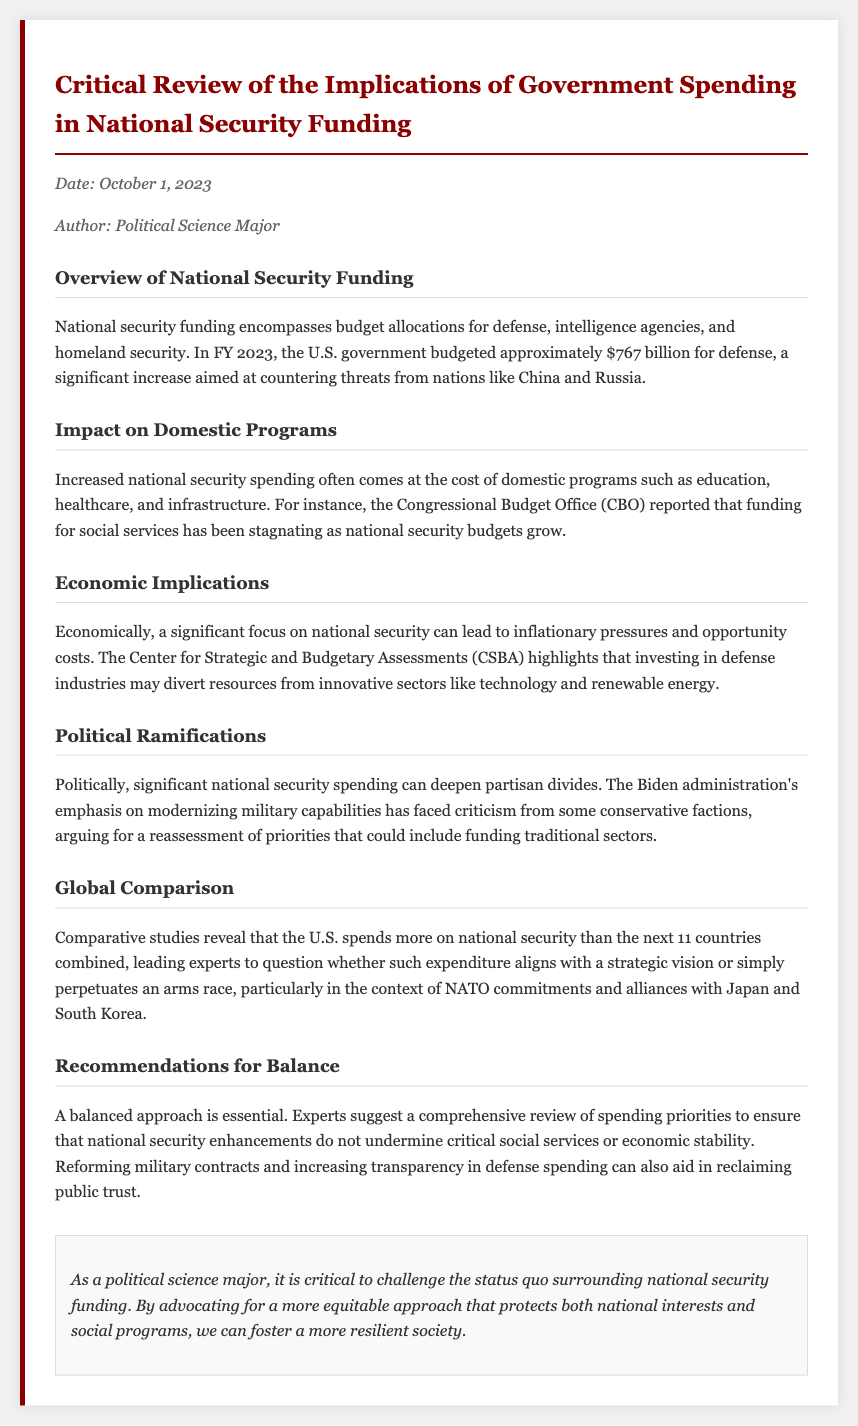What is the budgeted amount for defense in FY 2023? The document states that the U.S. government budgeted approximately $767 billion for defense in FY 2023.
Answer: $767 billion What impact does increased national security spending have on domestic programs? Increased national security spending often comes at the cost of domestic programs such as education and healthcare.
Answer: Cost What is one of the economic implications of focusing on national security? The document mentions inflationary pressures and opportunity costs as economic implications of significant focus on national security.
Answer: Inflationary pressures Which administration's military modernization has faced criticism from conservative factions? The Biden administration's emphasis on modernizing military capabilities is mentioned as facing criticism.
Answer: Biden administration How does U.S. national security spending compare globally? The document states that the U.S. spends more on national security than the next 11 countries combined.
Answer: More What do experts recommend to ensure balance in national security spending? The document suggests a comprehensive review of spending priorities to avoid undermining social services.
Answer: Comprehensive review What is a recommendation made for reclaiming public trust in defense spending? Reforming military contracts and increasing transparency is recommended to reclaim public trust.
Answer: Increasing transparency What is the date of this memo? The memo is dated October 1, 2023.
Answer: October 1, 2023 